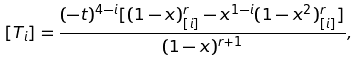Convert formula to latex. <formula><loc_0><loc_0><loc_500><loc_500>[ T _ { i } ] = \frac { ( - t ) ^ { 4 - i } [ ( 1 - x ) ^ { r } _ { [ i ] } - x ^ { 1 - i } ( 1 - x ^ { 2 } ) ^ { r } _ { [ i ] } ] } { ( 1 - x ) ^ { r + 1 } } ,</formula> 